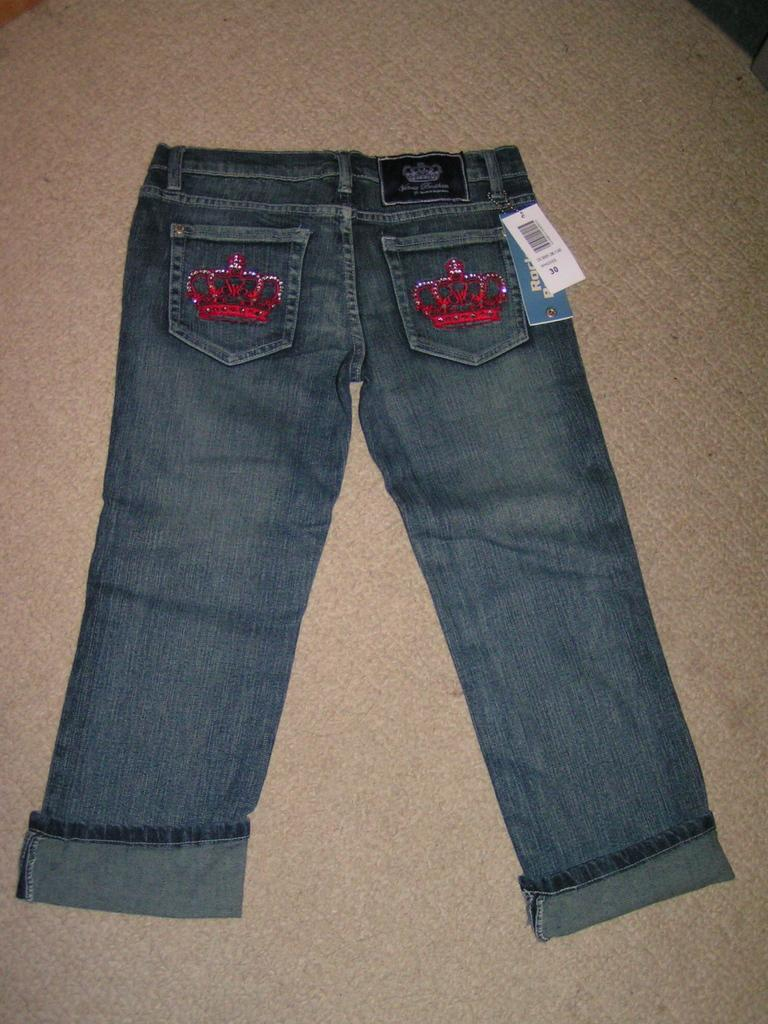What type of clothing item is in the image? There is a pair of jeans in the image. Where are the paper tags located in the image? The paper tags are on the right side of the image. What can be found on the paper tags? There is writing on the paper tags. What type of hydrant is visible in the image? There is no hydrant present in the image. How many men are working on the jeans in the image? There is no indication of men or any work being done on the jeans in the image. 